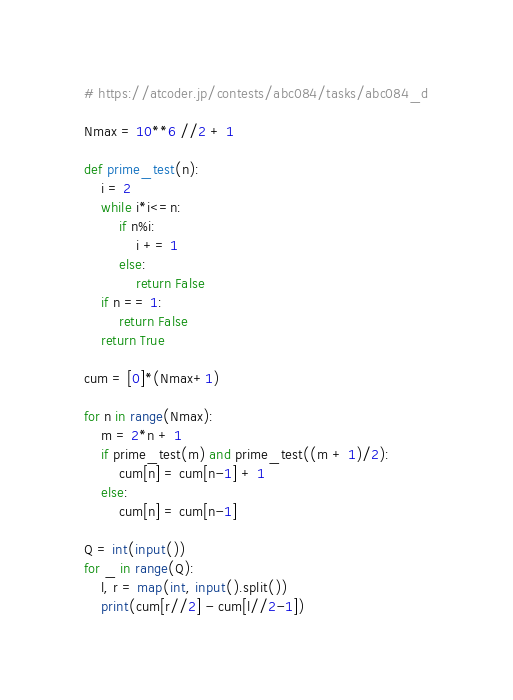Convert code to text. <code><loc_0><loc_0><loc_500><loc_500><_Python_># https://atcoder.jp/contests/abc084/tasks/abc084_d

Nmax = 10**6 //2 + 1

def prime_test(n):
    i = 2
    while i*i<=n:
        if n%i:
            i += 1
        else:
            return False
    if n == 1:
        return False
    return True

cum = [0]*(Nmax+1)

for n in range(Nmax):
    m = 2*n + 1
    if prime_test(m) and prime_test((m + 1)/2):
        cum[n] = cum[n-1] + 1
    else:
        cum[n] = cum[n-1]

Q = int(input())
for _ in range(Q):
    l, r = map(int, input().split())
    print(cum[r//2] - cum[l//2-1])</code> 